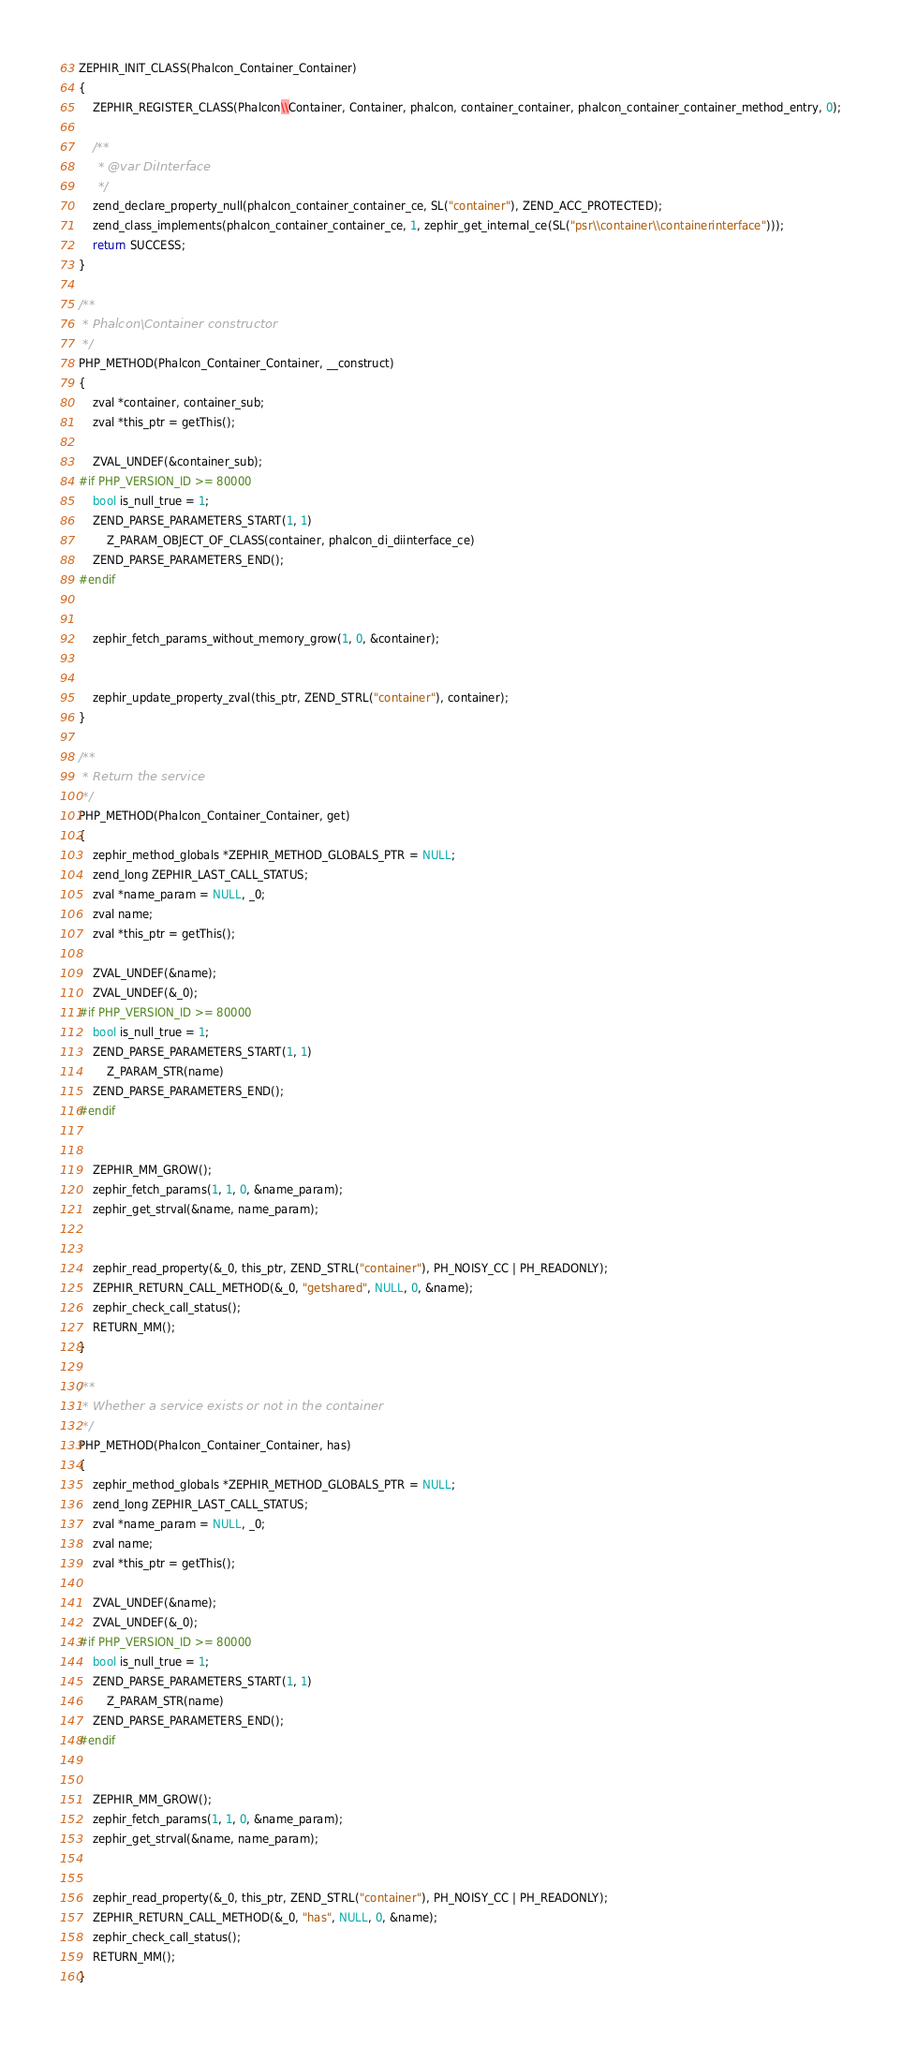<code> <loc_0><loc_0><loc_500><loc_500><_C_>ZEPHIR_INIT_CLASS(Phalcon_Container_Container)
{
	ZEPHIR_REGISTER_CLASS(Phalcon\\Container, Container, phalcon, container_container, phalcon_container_container_method_entry, 0);

	/**
	 * @var DiInterface
	 */
	zend_declare_property_null(phalcon_container_container_ce, SL("container"), ZEND_ACC_PROTECTED);
	zend_class_implements(phalcon_container_container_ce, 1, zephir_get_internal_ce(SL("psr\\container\\containerinterface")));
	return SUCCESS;
}

/**
 * Phalcon\Container constructor
 */
PHP_METHOD(Phalcon_Container_Container, __construct)
{
	zval *container, container_sub;
	zval *this_ptr = getThis();

	ZVAL_UNDEF(&container_sub);
#if PHP_VERSION_ID >= 80000
	bool is_null_true = 1;
	ZEND_PARSE_PARAMETERS_START(1, 1)
		Z_PARAM_OBJECT_OF_CLASS(container, phalcon_di_diinterface_ce)
	ZEND_PARSE_PARAMETERS_END();
#endif


	zephir_fetch_params_without_memory_grow(1, 0, &container);


	zephir_update_property_zval(this_ptr, ZEND_STRL("container"), container);
}

/**
 * Return the service
 */
PHP_METHOD(Phalcon_Container_Container, get)
{
	zephir_method_globals *ZEPHIR_METHOD_GLOBALS_PTR = NULL;
	zend_long ZEPHIR_LAST_CALL_STATUS;
	zval *name_param = NULL, _0;
	zval name;
	zval *this_ptr = getThis();

	ZVAL_UNDEF(&name);
	ZVAL_UNDEF(&_0);
#if PHP_VERSION_ID >= 80000
	bool is_null_true = 1;
	ZEND_PARSE_PARAMETERS_START(1, 1)
		Z_PARAM_STR(name)
	ZEND_PARSE_PARAMETERS_END();
#endif


	ZEPHIR_MM_GROW();
	zephir_fetch_params(1, 1, 0, &name_param);
	zephir_get_strval(&name, name_param);


	zephir_read_property(&_0, this_ptr, ZEND_STRL("container"), PH_NOISY_CC | PH_READONLY);
	ZEPHIR_RETURN_CALL_METHOD(&_0, "getshared", NULL, 0, &name);
	zephir_check_call_status();
	RETURN_MM();
}

/**
 * Whether a service exists or not in the container
 */
PHP_METHOD(Phalcon_Container_Container, has)
{
	zephir_method_globals *ZEPHIR_METHOD_GLOBALS_PTR = NULL;
	zend_long ZEPHIR_LAST_CALL_STATUS;
	zval *name_param = NULL, _0;
	zval name;
	zval *this_ptr = getThis();

	ZVAL_UNDEF(&name);
	ZVAL_UNDEF(&_0);
#if PHP_VERSION_ID >= 80000
	bool is_null_true = 1;
	ZEND_PARSE_PARAMETERS_START(1, 1)
		Z_PARAM_STR(name)
	ZEND_PARSE_PARAMETERS_END();
#endif


	ZEPHIR_MM_GROW();
	zephir_fetch_params(1, 1, 0, &name_param);
	zephir_get_strval(&name, name_param);


	zephir_read_property(&_0, this_ptr, ZEND_STRL("container"), PH_NOISY_CC | PH_READONLY);
	ZEPHIR_RETURN_CALL_METHOD(&_0, "has", NULL, 0, &name);
	zephir_check_call_status();
	RETURN_MM();
}

</code> 